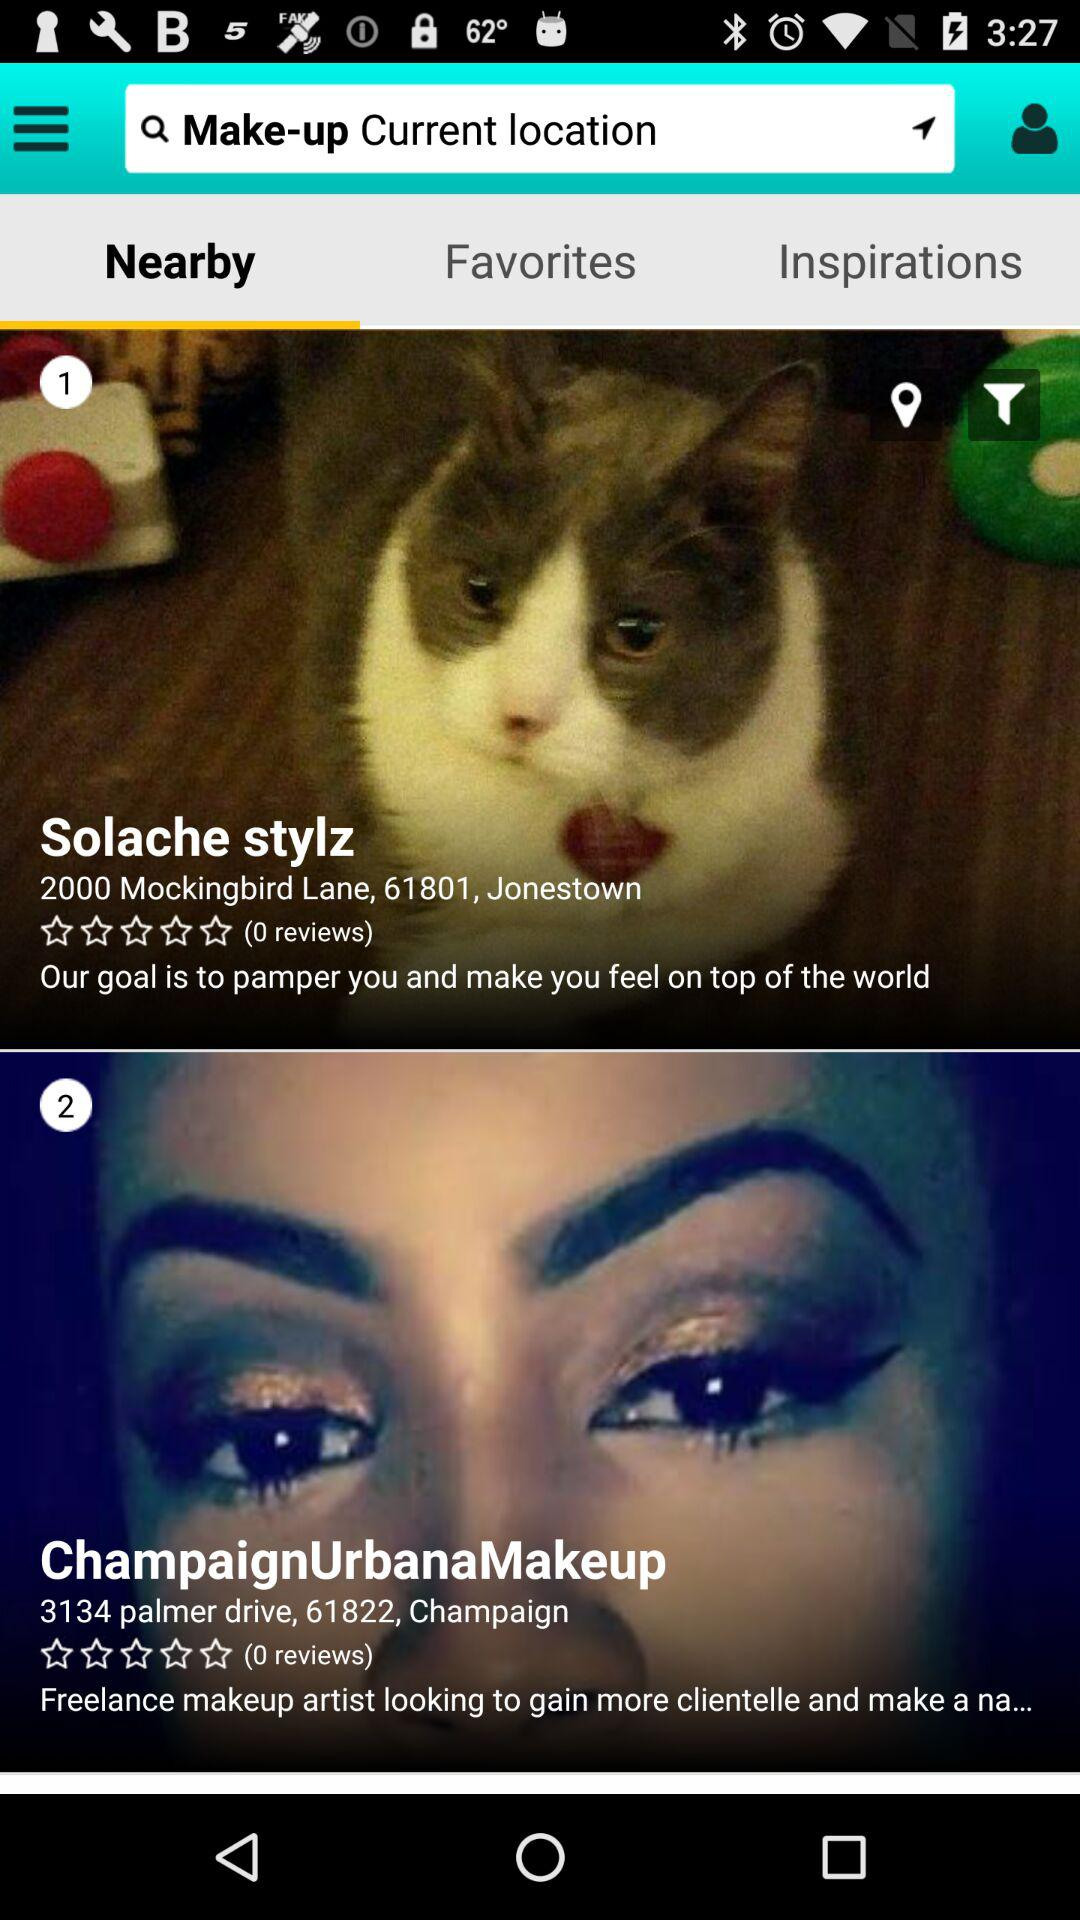Which tab is selected? The selected tab is "Nearby". 